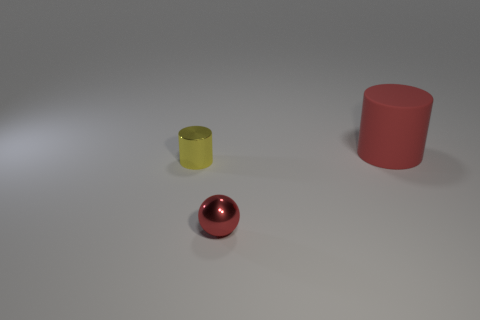Is the shape of the red thing that is in front of the red rubber thing the same as the red object that is behind the tiny yellow cylinder? Yes, both the red object in the foreground and the one partially obscured by the yellow cylinder in the background appear to be spheres, thereby having the same shape. 